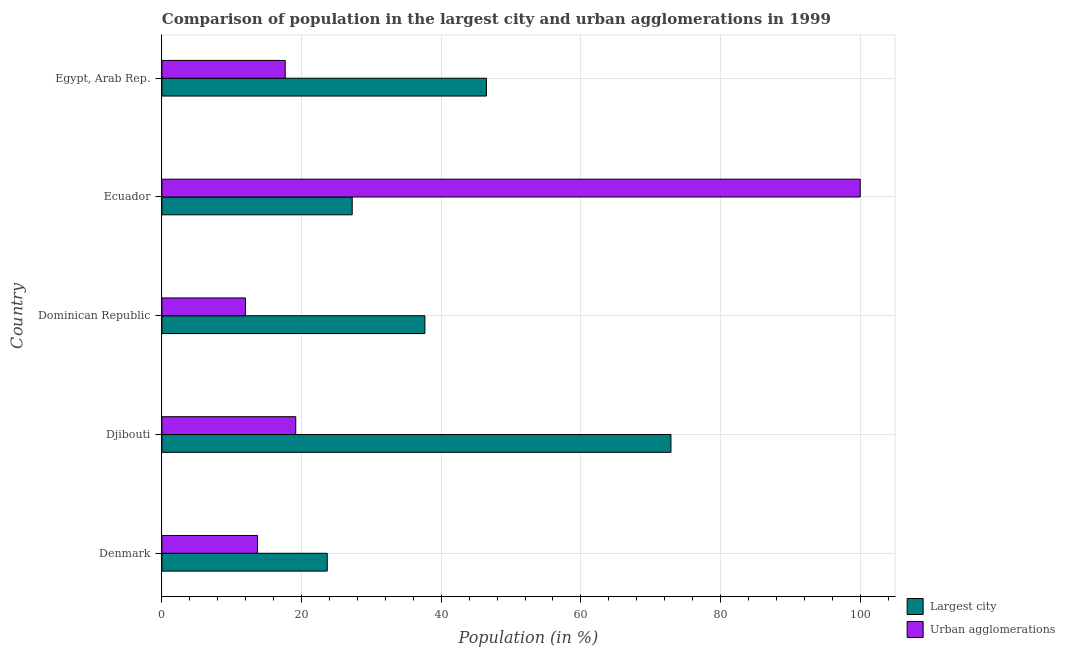Are the number of bars on each tick of the Y-axis equal?
Your answer should be compact. Yes. In how many cases, is the number of bars for a given country not equal to the number of legend labels?
Your answer should be compact. 0. What is the population in urban agglomerations in Djibouti?
Make the answer very short. 19.17. Across all countries, what is the maximum population in urban agglomerations?
Your response must be concise. 100. Across all countries, what is the minimum population in the largest city?
Your answer should be very brief. 23.68. In which country was the population in urban agglomerations maximum?
Give a very brief answer. Ecuador. In which country was the population in urban agglomerations minimum?
Provide a succinct answer. Dominican Republic. What is the total population in the largest city in the graph?
Keep it short and to the point. 207.97. What is the difference between the population in the largest city in Dominican Republic and that in Ecuador?
Ensure brevity in your answer.  10.41. What is the difference between the population in the largest city in Egypt, Arab Rep. and the population in urban agglomerations in Djibouti?
Keep it short and to the point. 27.31. What is the average population in urban agglomerations per country?
Ensure brevity in your answer.  32.49. What is the difference between the population in the largest city and population in urban agglomerations in Dominican Republic?
Ensure brevity in your answer.  25.7. In how many countries, is the population in urban agglomerations greater than 76 %?
Provide a succinct answer. 1. What is the ratio of the population in urban agglomerations in Denmark to that in Dominican Republic?
Your response must be concise. 1.14. Is the difference between the population in the largest city in Djibouti and Dominican Republic greater than the difference between the population in urban agglomerations in Djibouti and Dominican Republic?
Offer a very short reply. Yes. What is the difference between the highest and the second highest population in urban agglomerations?
Your answer should be compact. 80.83. What is the difference between the highest and the lowest population in urban agglomerations?
Your response must be concise. 88.04. What does the 1st bar from the top in Egypt, Arab Rep. represents?
Offer a very short reply. Urban agglomerations. What does the 1st bar from the bottom in Ecuador represents?
Ensure brevity in your answer.  Largest city. How many bars are there?
Provide a short and direct response. 10. How many countries are there in the graph?
Provide a succinct answer. 5. Are the values on the major ticks of X-axis written in scientific E-notation?
Keep it short and to the point. No. Does the graph contain grids?
Keep it short and to the point. Yes. Where does the legend appear in the graph?
Provide a short and direct response. Bottom right. How many legend labels are there?
Offer a terse response. 2. What is the title of the graph?
Provide a succinct answer. Comparison of population in the largest city and urban agglomerations in 1999. Does "Passenger Transport Items" appear as one of the legend labels in the graph?
Provide a succinct answer. No. What is the label or title of the X-axis?
Provide a short and direct response. Population (in %). What is the Population (in %) in Largest city in Denmark?
Ensure brevity in your answer.  23.68. What is the Population (in %) in Urban agglomerations in Denmark?
Give a very brief answer. 13.69. What is the Population (in %) in Largest city in Djibouti?
Keep it short and to the point. 72.9. What is the Population (in %) in Urban agglomerations in Djibouti?
Provide a short and direct response. 19.17. What is the Population (in %) of Largest city in Dominican Republic?
Offer a terse response. 37.66. What is the Population (in %) of Urban agglomerations in Dominican Republic?
Give a very brief answer. 11.96. What is the Population (in %) of Largest city in Ecuador?
Keep it short and to the point. 27.25. What is the Population (in %) of Urban agglomerations in Ecuador?
Your answer should be very brief. 100. What is the Population (in %) of Largest city in Egypt, Arab Rep.?
Your response must be concise. 46.48. What is the Population (in %) of Urban agglomerations in Egypt, Arab Rep.?
Provide a short and direct response. 17.66. Across all countries, what is the maximum Population (in %) in Largest city?
Keep it short and to the point. 72.9. Across all countries, what is the minimum Population (in %) of Largest city?
Ensure brevity in your answer.  23.68. Across all countries, what is the minimum Population (in %) of Urban agglomerations?
Provide a short and direct response. 11.96. What is the total Population (in %) in Largest city in the graph?
Ensure brevity in your answer.  207.97. What is the total Population (in %) of Urban agglomerations in the graph?
Make the answer very short. 162.47. What is the difference between the Population (in %) in Largest city in Denmark and that in Djibouti?
Provide a succinct answer. -49.22. What is the difference between the Population (in %) of Urban agglomerations in Denmark and that in Djibouti?
Ensure brevity in your answer.  -5.48. What is the difference between the Population (in %) of Largest city in Denmark and that in Dominican Republic?
Offer a terse response. -13.98. What is the difference between the Population (in %) of Urban agglomerations in Denmark and that in Dominican Republic?
Your answer should be compact. 1.72. What is the difference between the Population (in %) in Largest city in Denmark and that in Ecuador?
Give a very brief answer. -3.57. What is the difference between the Population (in %) in Urban agglomerations in Denmark and that in Ecuador?
Make the answer very short. -86.31. What is the difference between the Population (in %) in Largest city in Denmark and that in Egypt, Arab Rep.?
Provide a short and direct response. -22.8. What is the difference between the Population (in %) of Urban agglomerations in Denmark and that in Egypt, Arab Rep.?
Provide a short and direct response. -3.97. What is the difference between the Population (in %) in Largest city in Djibouti and that in Dominican Republic?
Give a very brief answer. 35.23. What is the difference between the Population (in %) of Urban agglomerations in Djibouti and that in Dominican Republic?
Keep it short and to the point. 7.21. What is the difference between the Population (in %) in Largest city in Djibouti and that in Ecuador?
Your answer should be compact. 45.65. What is the difference between the Population (in %) of Urban agglomerations in Djibouti and that in Ecuador?
Your answer should be very brief. -80.83. What is the difference between the Population (in %) in Largest city in Djibouti and that in Egypt, Arab Rep.?
Offer a terse response. 26.42. What is the difference between the Population (in %) of Urban agglomerations in Djibouti and that in Egypt, Arab Rep.?
Your answer should be very brief. 1.51. What is the difference between the Population (in %) of Largest city in Dominican Republic and that in Ecuador?
Offer a terse response. 10.41. What is the difference between the Population (in %) of Urban agglomerations in Dominican Republic and that in Ecuador?
Your answer should be very brief. -88.04. What is the difference between the Population (in %) of Largest city in Dominican Republic and that in Egypt, Arab Rep.?
Provide a short and direct response. -8.81. What is the difference between the Population (in %) in Urban agglomerations in Dominican Republic and that in Egypt, Arab Rep.?
Provide a short and direct response. -5.7. What is the difference between the Population (in %) in Largest city in Ecuador and that in Egypt, Arab Rep.?
Your answer should be very brief. -19.23. What is the difference between the Population (in %) of Urban agglomerations in Ecuador and that in Egypt, Arab Rep.?
Offer a terse response. 82.34. What is the difference between the Population (in %) of Largest city in Denmark and the Population (in %) of Urban agglomerations in Djibouti?
Give a very brief answer. 4.51. What is the difference between the Population (in %) of Largest city in Denmark and the Population (in %) of Urban agglomerations in Dominican Republic?
Your answer should be very brief. 11.72. What is the difference between the Population (in %) of Largest city in Denmark and the Population (in %) of Urban agglomerations in Ecuador?
Offer a terse response. -76.32. What is the difference between the Population (in %) in Largest city in Denmark and the Population (in %) in Urban agglomerations in Egypt, Arab Rep.?
Offer a very short reply. 6.02. What is the difference between the Population (in %) in Largest city in Djibouti and the Population (in %) in Urban agglomerations in Dominican Republic?
Offer a terse response. 60.93. What is the difference between the Population (in %) of Largest city in Djibouti and the Population (in %) of Urban agglomerations in Ecuador?
Ensure brevity in your answer.  -27.1. What is the difference between the Population (in %) in Largest city in Djibouti and the Population (in %) in Urban agglomerations in Egypt, Arab Rep.?
Make the answer very short. 55.24. What is the difference between the Population (in %) in Largest city in Dominican Republic and the Population (in %) in Urban agglomerations in Ecuador?
Keep it short and to the point. -62.34. What is the difference between the Population (in %) in Largest city in Dominican Republic and the Population (in %) in Urban agglomerations in Egypt, Arab Rep.?
Provide a short and direct response. 20. What is the difference between the Population (in %) of Largest city in Ecuador and the Population (in %) of Urban agglomerations in Egypt, Arab Rep.?
Offer a very short reply. 9.59. What is the average Population (in %) in Largest city per country?
Your response must be concise. 41.59. What is the average Population (in %) in Urban agglomerations per country?
Your answer should be very brief. 32.49. What is the difference between the Population (in %) in Largest city and Population (in %) in Urban agglomerations in Denmark?
Give a very brief answer. 9.99. What is the difference between the Population (in %) in Largest city and Population (in %) in Urban agglomerations in Djibouti?
Offer a terse response. 53.73. What is the difference between the Population (in %) in Largest city and Population (in %) in Urban agglomerations in Dominican Republic?
Keep it short and to the point. 25.7. What is the difference between the Population (in %) of Largest city and Population (in %) of Urban agglomerations in Ecuador?
Ensure brevity in your answer.  -72.75. What is the difference between the Population (in %) in Largest city and Population (in %) in Urban agglomerations in Egypt, Arab Rep.?
Keep it short and to the point. 28.82. What is the ratio of the Population (in %) in Largest city in Denmark to that in Djibouti?
Provide a short and direct response. 0.32. What is the ratio of the Population (in %) in Urban agglomerations in Denmark to that in Djibouti?
Ensure brevity in your answer.  0.71. What is the ratio of the Population (in %) in Largest city in Denmark to that in Dominican Republic?
Give a very brief answer. 0.63. What is the ratio of the Population (in %) in Urban agglomerations in Denmark to that in Dominican Republic?
Your answer should be very brief. 1.14. What is the ratio of the Population (in %) in Largest city in Denmark to that in Ecuador?
Keep it short and to the point. 0.87. What is the ratio of the Population (in %) in Urban agglomerations in Denmark to that in Ecuador?
Provide a succinct answer. 0.14. What is the ratio of the Population (in %) of Largest city in Denmark to that in Egypt, Arab Rep.?
Make the answer very short. 0.51. What is the ratio of the Population (in %) of Urban agglomerations in Denmark to that in Egypt, Arab Rep.?
Provide a short and direct response. 0.78. What is the ratio of the Population (in %) in Largest city in Djibouti to that in Dominican Republic?
Make the answer very short. 1.94. What is the ratio of the Population (in %) of Urban agglomerations in Djibouti to that in Dominican Republic?
Offer a very short reply. 1.6. What is the ratio of the Population (in %) in Largest city in Djibouti to that in Ecuador?
Ensure brevity in your answer.  2.67. What is the ratio of the Population (in %) of Urban agglomerations in Djibouti to that in Ecuador?
Your response must be concise. 0.19. What is the ratio of the Population (in %) in Largest city in Djibouti to that in Egypt, Arab Rep.?
Your answer should be compact. 1.57. What is the ratio of the Population (in %) of Urban agglomerations in Djibouti to that in Egypt, Arab Rep.?
Offer a very short reply. 1.09. What is the ratio of the Population (in %) of Largest city in Dominican Republic to that in Ecuador?
Your response must be concise. 1.38. What is the ratio of the Population (in %) of Urban agglomerations in Dominican Republic to that in Ecuador?
Give a very brief answer. 0.12. What is the ratio of the Population (in %) of Largest city in Dominican Republic to that in Egypt, Arab Rep.?
Keep it short and to the point. 0.81. What is the ratio of the Population (in %) in Urban agglomerations in Dominican Republic to that in Egypt, Arab Rep.?
Keep it short and to the point. 0.68. What is the ratio of the Population (in %) of Largest city in Ecuador to that in Egypt, Arab Rep.?
Your answer should be very brief. 0.59. What is the ratio of the Population (in %) of Urban agglomerations in Ecuador to that in Egypt, Arab Rep.?
Keep it short and to the point. 5.66. What is the difference between the highest and the second highest Population (in %) in Largest city?
Ensure brevity in your answer.  26.42. What is the difference between the highest and the second highest Population (in %) of Urban agglomerations?
Keep it short and to the point. 80.83. What is the difference between the highest and the lowest Population (in %) of Largest city?
Your answer should be compact. 49.22. What is the difference between the highest and the lowest Population (in %) of Urban agglomerations?
Your answer should be very brief. 88.04. 